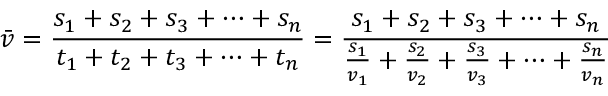Convert formula to latex. <formula><loc_0><loc_0><loc_500><loc_500>{ \bar { v } } = { \frac { s _ { 1 } + s _ { 2 } + s _ { 3 } + \dots + s _ { n } } { t _ { 1 } + t _ { 2 } + t _ { 3 } + \dots + t _ { n } } } = { \frac { s _ { 1 } + s _ { 2 } + s _ { 3 } + \dots + s _ { n } } { { \frac { s _ { 1 } } { v _ { 1 } } } + { \frac { s _ { 2 } } { v _ { 2 } } } + { \frac { s _ { 3 } } { v _ { 3 } } } + \dots + { \frac { s _ { n } } { v _ { n } } } } }</formula> 